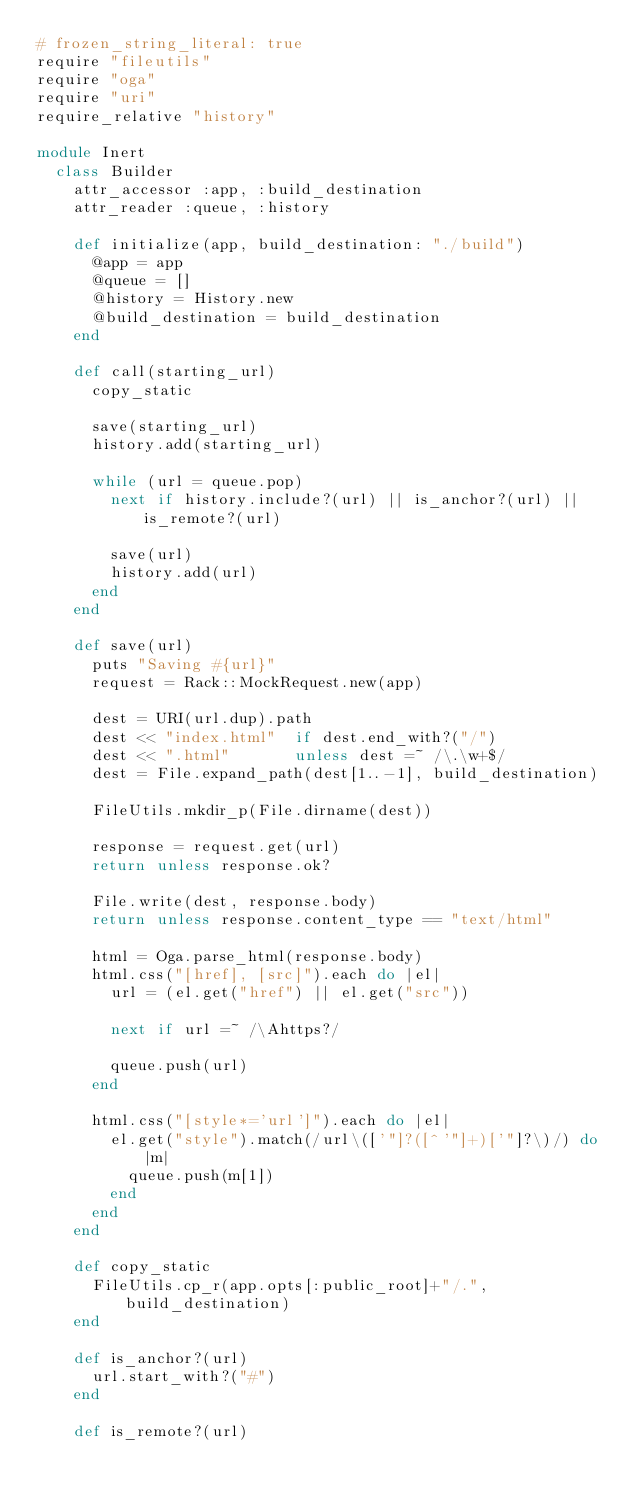Convert code to text. <code><loc_0><loc_0><loc_500><loc_500><_Ruby_># frozen_string_literal: true
require "fileutils"
require "oga"
require "uri"
require_relative "history"

module Inert
  class Builder
    attr_accessor :app, :build_destination
    attr_reader :queue, :history

    def initialize(app, build_destination: "./build")
      @app = app
      @queue = []
      @history = History.new
      @build_destination = build_destination
    end

    def call(starting_url)
      copy_static

      save(starting_url)
      history.add(starting_url)

      while (url = queue.pop)
        next if history.include?(url) || is_anchor?(url) || is_remote?(url)

        save(url)
        history.add(url)
      end
    end

    def save(url)
      puts "Saving #{url}"
      request = Rack::MockRequest.new(app)

      dest = URI(url.dup).path
      dest << "index.html"  if dest.end_with?("/")
      dest << ".html"       unless dest =~ /\.\w+$/
      dest = File.expand_path(dest[1..-1], build_destination)

      FileUtils.mkdir_p(File.dirname(dest))

      response = request.get(url)
      return unless response.ok?

      File.write(dest, response.body)
      return unless response.content_type == "text/html"

      html = Oga.parse_html(response.body)
      html.css("[href], [src]").each do |el|
        url = (el.get("href") || el.get("src"))

        next if url =~ /\Ahttps?/

        queue.push(url)
      end

      html.css("[style*='url']").each do |el|
        el.get("style").match(/url\(['"]?([^'"]+)['"]?\)/) do |m|
          queue.push(m[1])
        end
      end
    end

    def copy_static
      FileUtils.cp_r(app.opts[:public_root]+"/.", build_destination)
    end

    def is_anchor?(url)
      url.start_with?("#")
    end

    def is_remote?(url)</code> 